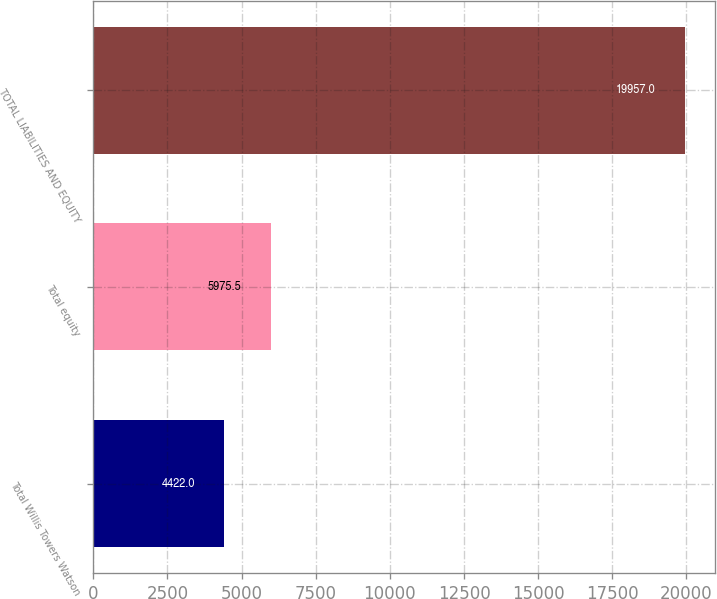<chart> <loc_0><loc_0><loc_500><loc_500><bar_chart><fcel>Total Willis Towers Watson<fcel>Total equity<fcel>TOTAL LIABILITIES AND EQUITY<nl><fcel>4422<fcel>5975.5<fcel>19957<nl></chart> 